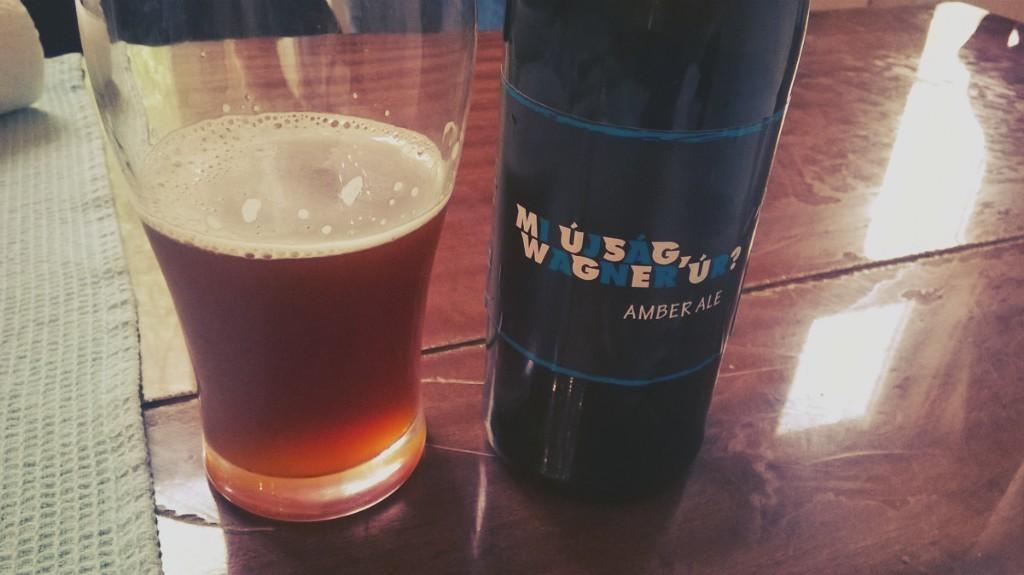Provide a one-sentence caption for the provided image. A bottle of Mi ujsag, Wagner ur? amber ale next to a glass that is half full of beer. 